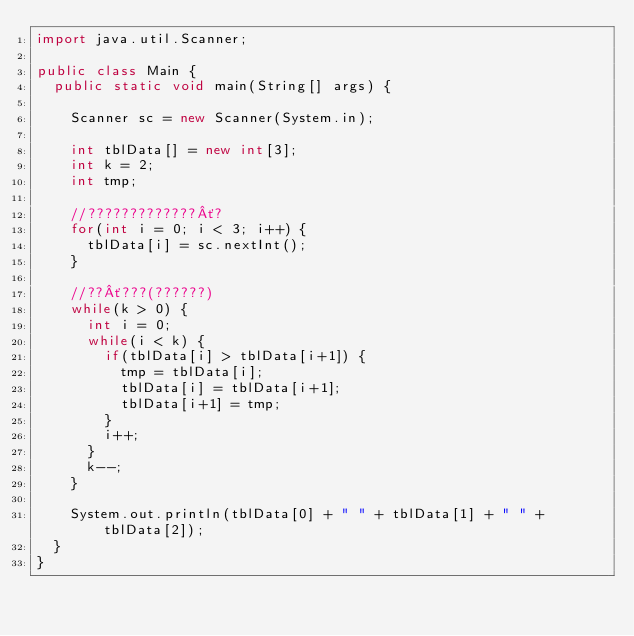<code> <loc_0><loc_0><loc_500><loc_500><_Java_>import java.util.Scanner;

public class Main {
	public static void main(String[] args) {
		
		Scanner sc = new Scanner(System.in);
		
		int tblData[] = new int[3];
		int k = 2;
		int tmp;
		
		//?????????????´?
		for(int i = 0; i < 3; i++) {
			tblData[i] = sc.nextInt();
		}
		
		//??´???(??????)
		while(k > 0) {
			int i = 0;
			while(i < k) {
				if(tblData[i] > tblData[i+1]) {
					tmp = tblData[i];
					tblData[i] = tblData[i+1];
					tblData[i+1] = tmp;
				}
				i++;
			}
			k--;
		}
		
		System.out.println(tblData[0] + " " + tblData[1] + " " + tblData[2]);
	}
}</code> 